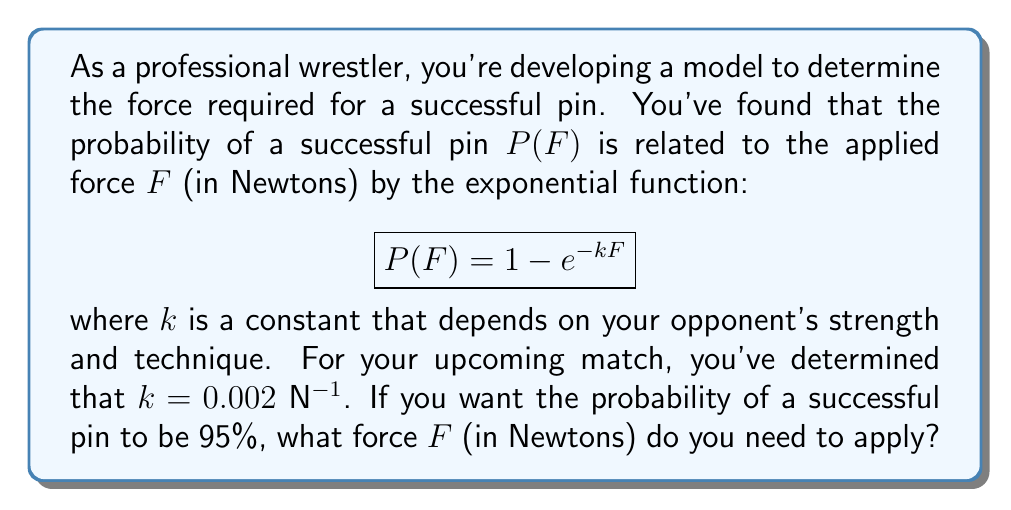Help me with this question. To solve this problem, we'll follow these steps:

1) We're given the probability function: $P(F) = 1 - e^{-kF}$
   Where $k = 0.002$ N$^{-1}$ and we want $P(F) = 0.95$

2) Let's substitute these values into the equation:
   $$0.95 = 1 - e^{-0.002F}$$

3) Subtract both sides from 1:
   $$0.05 = e^{-0.002F}$$

4) Take the natural logarithm of both sides:
   $$\ln(0.05) = -0.002F$$

5) Multiply both sides by -1:
   $$-\ln(0.05) = 0.002F$$

6) Divide both sides by 0.002:
   $$\frac{-\ln(0.05)}{0.002} = F$$

7) Calculate the value:
   $$F = \frac{-\ln(0.05)}{0.002} \approx 1498.6\text{ N}$$

Therefore, you need to apply approximately 1498.6 Newtons of force for a 95% probability of a successful pin.
Answer: $F \approx 1498.6\text{ N}$ 